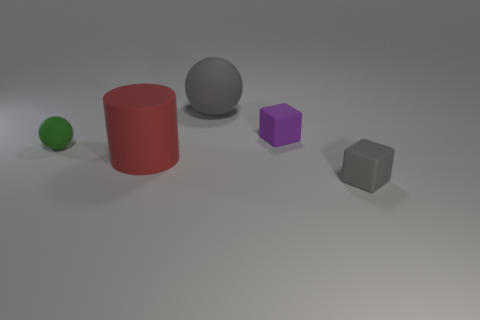There is a matte object in front of the large red object; does it have the same color as the big sphere?
Keep it short and to the point. Yes. Is there anything else that is the same color as the large ball?
Provide a succinct answer. Yes. Is there a large brown sphere?
Give a very brief answer. No. There is a cube that is behind the tiny object to the left of the red matte thing; what is its size?
Your answer should be very brief. Small. Is the color of the big rubber object to the left of the big gray rubber sphere the same as the sphere that is in front of the big rubber sphere?
Offer a very short reply. No. There is a thing that is on the left side of the purple block and right of the large red matte cylinder; what color is it?
Give a very brief answer. Gray. How many other things are the same shape as the small purple object?
Provide a short and direct response. 1. The other matte block that is the same size as the purple rubber cube is what color?
Offer a very short reply. Gray. The small cube that is left of the gray block is what color?
Offer a terse response. Purple. There is a matte sphere that is right of the cylinder; is there a gray object on the right side of it?
Keep it short and to the point. Yes. 